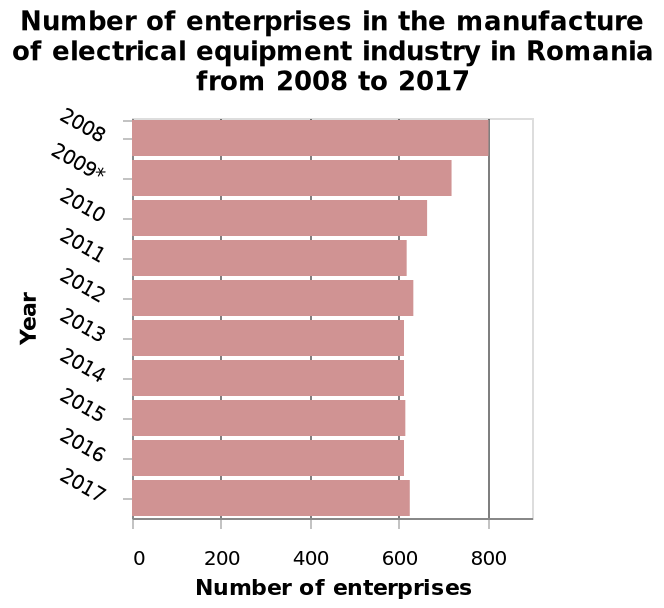<image>
What is the overall trend in the number of enterprises in the manufacture of electrical equipment industry in Romania from 2008 to 2017? The overall trend in the number of enterprises in the manufacture of electrical equipment industry in Romania from 2008 to 2017 is a decrease, with the number becoming basically stable from 2011 until 2017. please summary the statistics and relations of the chart The graphic show us that from 2008 until 2017 we can assist a decrease 8n the number of enterprises in the manufacture of electrical equipment industry in romania . The highest number observed was in 2008 with 800 enterprises in operation. From that year it's visible a decrease in the number of enterprises 5hat become basically stable from 2011 until 2017. How many years does the bar graph represent?  The bar graph represents a period of 10 years, from 2008 to 2017. When did the decrease in the number of enterprises in the manufacture of electrical equipment industry in Romania become stable? The decrease in the number of enterprises in the manufacture of electrical equipment industry in Romania became stable from 2011 until 2017. What does the y-axis measure in the bar graph?  The y-axis measures the Year. What was the starting year for the decrease in the number of enterprises in the manufacture of electrical equipment industry in Romania? The starting year for the decrease in the number of enterprises in the manufacture of electrical equipment industry in Romania was 2008. What was the trend in the Number of enterprises in the manufacture of electrical equipment industry in Romania from 2008 to 2017? The bar graph does not provide information on the trend in the Number of enterprises over the given period. Does the bar graph provide information on the trend in the Number of enterprises over the given period? No.The bar graph does not provide information on the trend in the Number of enterprises over the given period. 